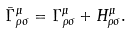Convert formula to latex. <formula><loc_0><loc_0><loc_500><loc_500>\bar { \Gamma } ^ { \mu } _ { \rho \sigma } = \Gamma ^ { \mu } _ { \rho \sigma } + H ^ { \mu } _ { \rho \sigma } .</formula> 